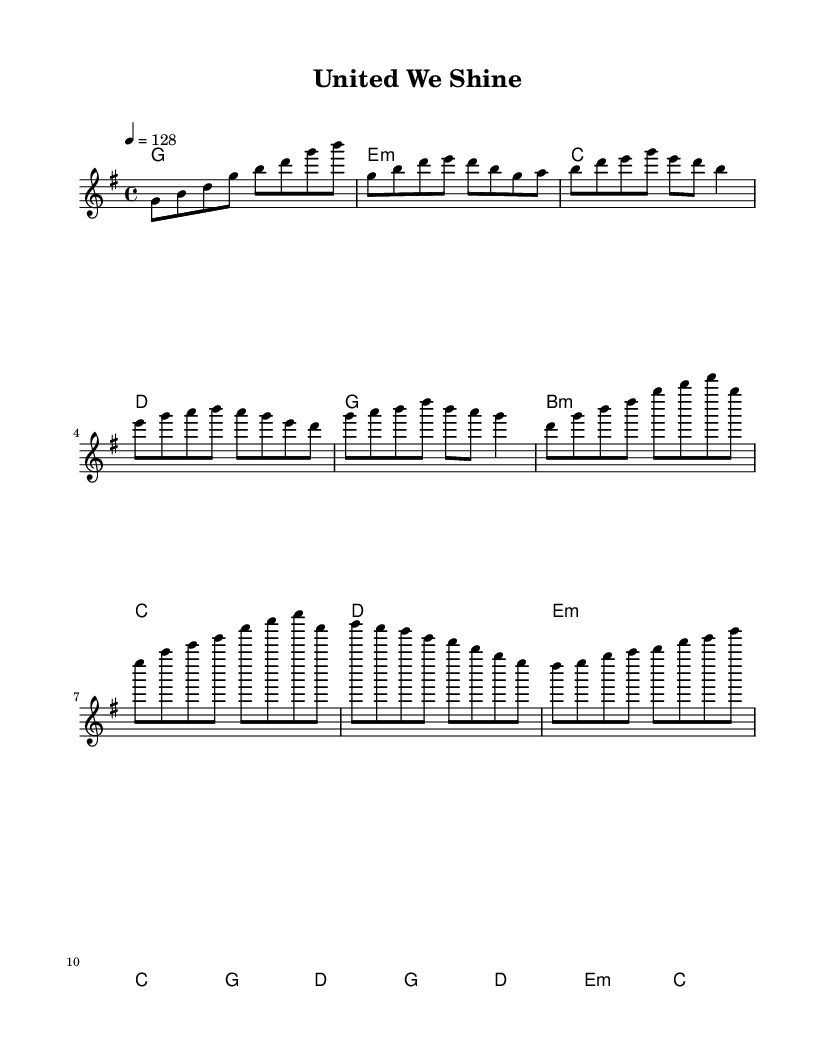What is the key signature of this music? The key signature is G major, which has one sharp (F#). This can be determined by looking at the key indicated in the global section of the code, which states `\key g \major`.
Answer: G major What is the time signature of this music? The time signature is 4/4, as indicated by the notation `\time 4/4` in the global section. This means there are four beats in each measure.
Answer: 4/4 What is the tempo marking of this piece? The tempo marking is 128 beats per minute, which is specified by the notation `\tempo 4 = 128`. This tells performers how fast to play the music.
Answer: 128 What is the first note of the melody? The first note of the melody is G, which is found at the beginning of the melody section. It is indicated as `g8`, representing an eighth note.
Answer: G Which chord is played at the beginning of the piece? The chord played at the beginning is G major, indicated by the notation `g1` in the harmonies section. This signifies that the G major chord should sound at the start of the piece.
Answer: G How many measures are in the chorus section? The chorus section contains 2 measures, as seen from the structure of the melody where two groupings of notes are provided before the next musical section.
Answer: 2 What musical feature characterizes K-Pop anthems reflected in this sheet music? The musical feature is its upbeat tempo combined with catchy melodies and harmonies that emphasize teamwork, particularly evident in the repeated use of chords and uplifting motifs. This reflects the typical celebration of collaboration commonly found in K-Pop dance anthems.
Answer: Upbeat tempo and catchy melodies 